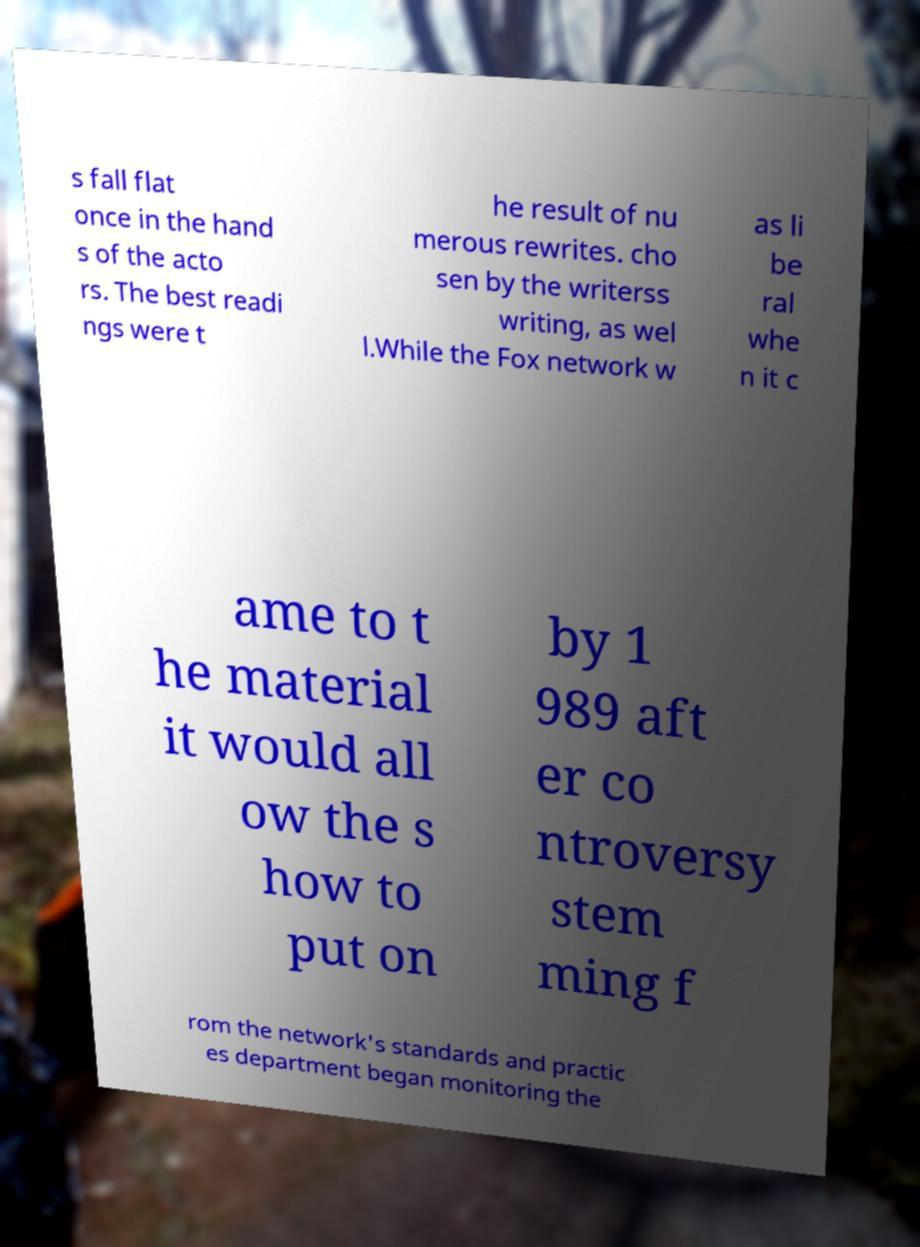Can you read and provide the text displayed in the image?This photo seems to have some interesting text. Can you extract and type it out for me? s fall flat once in the hand s of the acto rs. The best readi ngs were t he result of nu merous rewrites. cho sen by the writerss writing, as wel l.While the Fox network w as li be ral whe n it c ame to t he material it would all ow the s how to put on by 1 989 aft er co ntroversy stem ming f rom the network's standards and practic es department began monitoring the 